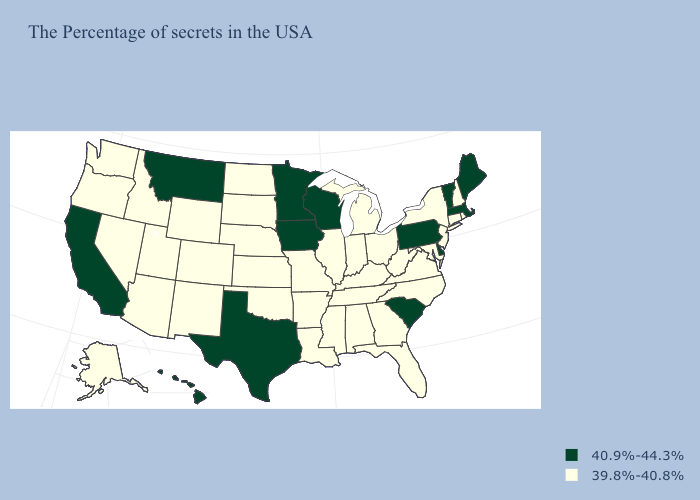What is the value of Pennsylvania?
Keep it brief. 40.9%-44.3%. Does New Mexico have the same value as South Dakota?
Concise answer only. Yes. Name the states that have a value in the range 40.9%-44.3%?
Answer briefly. Maine, Massachusetts, Vermont, Delaware, Pennsylvania, South Carolina, Wisconsin, Minnesota, Iowa, Texas, Montana, California, Hawaii. Which states have the lowest value in the USA?
Quick response, please. Rhode Island, New Hampshire, Connecticut, New York, New Jersey, Maryland, Virginia, North Carolina, West Virginia, Ohio, Florida, Georgia, Michigan, Kentucky, Indiana, Alabama, Tennessee, Illinois, Mississippi, Louisiana, Missouri, Arkansas, Kansas, Nebraska, Oklahoma, South Dakota, North Dakota, Wyoming, Colorado, New Mexico, Utah, Arizona, Idaho, Nevada, Washington, Oregon, Alaska. What is the value of Texas?
Answer briefly. 40.9%-44.3%. How many symbols are there in the legend?
Keep it brief. 2. What is the lowest value in the USA?
Concise answer only. 39.8%-40.8%. What is the lowest value in the USA?
Quick response, please. 39.8%-40.8%. Name the states that have a value in the range 40.9%-44.3%?
Quick response, please. Maine, Massachusetts, Vermont, Delaware, Pennsylvania, South Carolina, Wisconsin, Minnesota, Iowa, Texas, Montana, California, Hawaii. Does Pennsylvania have a lower value than Louisiana?
Concise answer only. No. What is the highest value in states that border Maryland?
Write a very short answer. 40.9%-44.3%. Does Nevada have a lower value than Minnesota?
Give a very brief answer. Yes. Which states have the highest value in the USA?
Quick response, please. Maine, Massachusetts, Vermont, Delaware, Pennsylvania, South Carolina, Wisconsin, Minnesota, Iowa, Texas, Montana, California, Hawaii. 